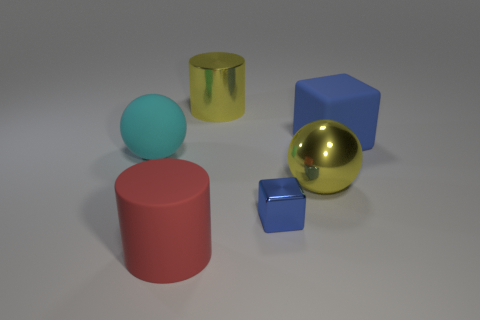Is there anything else that is the same size as the metal cube?
Provide a short and direct response. No. How many matte objects are large yellow cylinders or balls?
Your answer should be very brief. 1. Are there any big metallic objects of the same color as the large metallic cylinder?
Your response must be concise. Yes. Are any rubber blocks visible?
Your answer should be compact. Yes. Do the small blue shiny object and the large blue matte thing have the same shape?
Ensure brevity in your answer.  Yes. What number of large objects are yellow objects or blue matte cubes?
Ensure brevity in your answer.  3. What color is the big shiny cylinder?
Your answer should be compact. Yellow. What is the shape of the big yellow shiny thing that is in front of the large metal object behind the large yellow ball?
Offer a very short reply. Sphere. Are there any other large cylinders that have the same material as the yellow cylinder?
Your answer should be compact. No. There is a metal object that is behind the cyan rubber object; does it have the same size as the blue shiny block?
Offer a very short reply. No. 